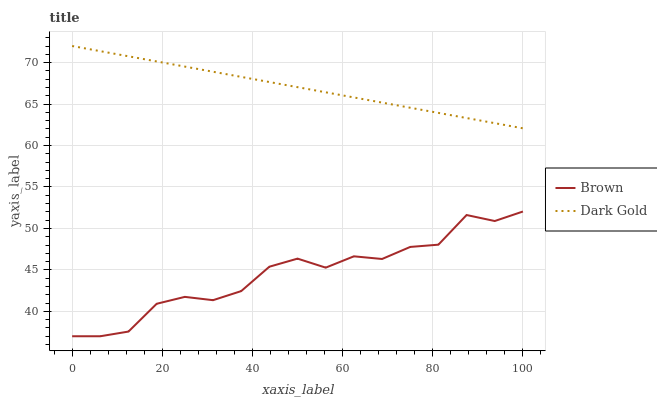Does Dark Gold have the minimum area under the curve?
Answer yes or no. No. Is Dark Gold the roughest?
Answer yes or no. No. Does Dark Gold have the lowest value?
Answer yes or no. No. Is Brown less than Dark Gold?
Answer yes or no. Yes. Is Dark Gold greater than Brown?
Answer yes or no. Yes. Does Brown intersect Dark Gold?
Answer yes or no. No. 